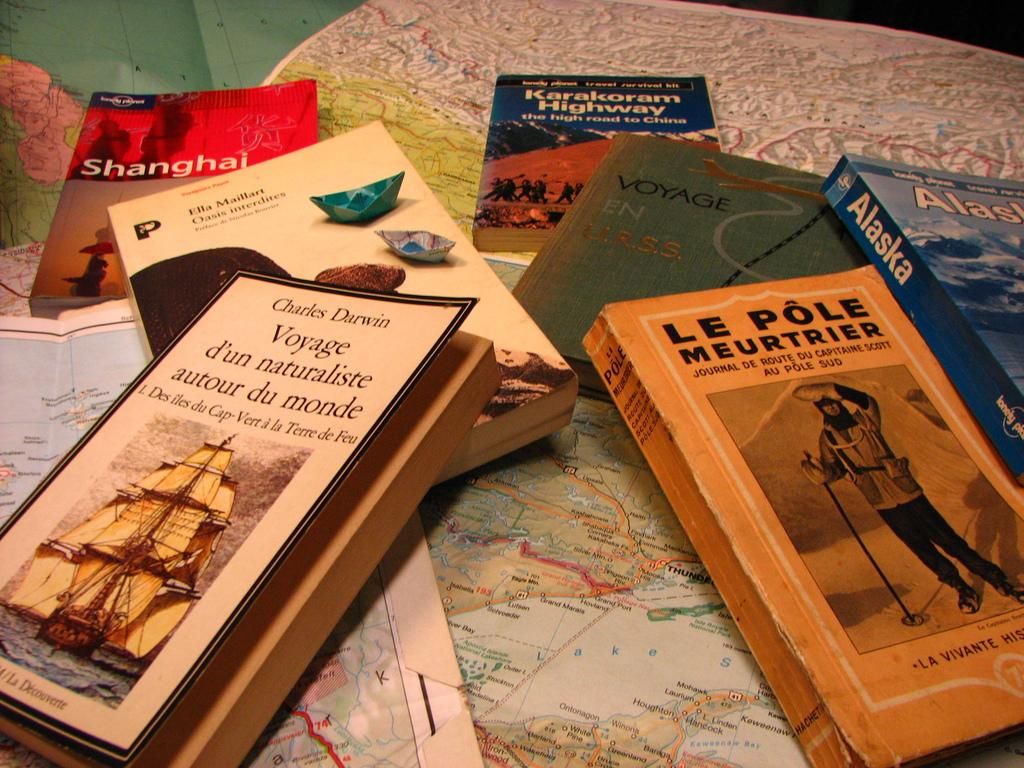<image>
Describe the image concisely. books next to one another with one called 'le pole meutrier' 